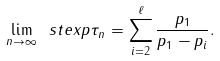<formula> <loc_0><loc_0><loc_500><loc_500>\lim _ { n \rightarrow \infty } \ s t e x p \tau _ { n } = \sum _ { i = 2 } ^ { \ell } \frac { p _ { 1 } } { p _ { 1 } - p _ { i } } .</formula> 